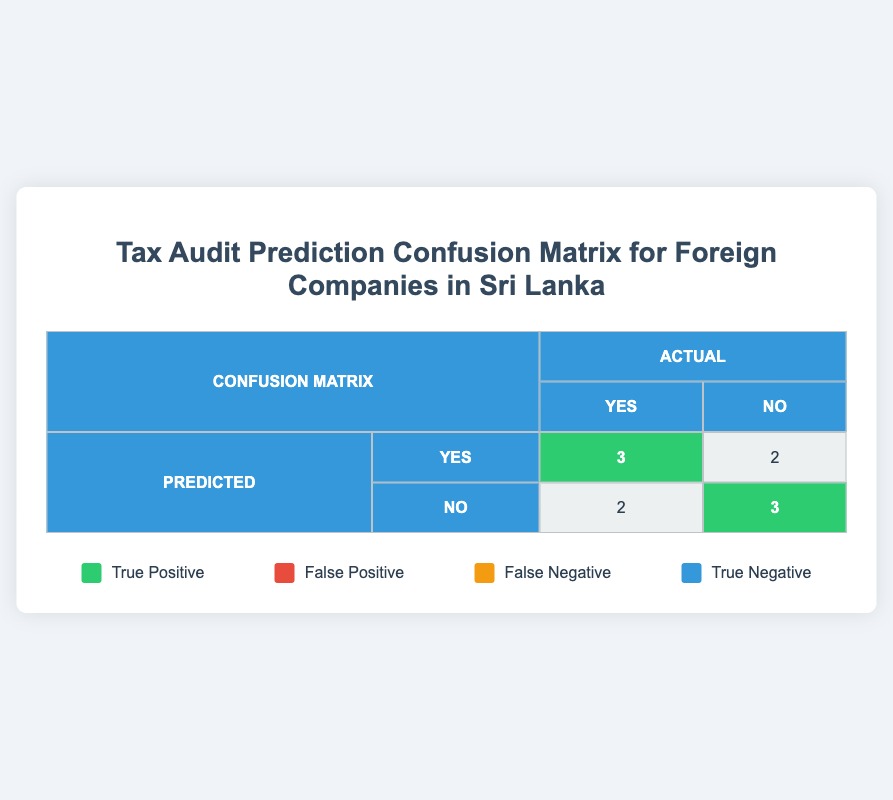What is the number of true positives? The number of true positives is represented by the cell in the first row and first column, which shows 3 instances where the predicted audit was "Yes," and the actual audit was also "Yes."
Answer: 3 How many companies were predicted to have an audit but did not actually have one? This is the number of false positives, represented by the cell in the first row and second column. It shows 2 instances where the predicted audit was "Yes," but the actual audit was "No."
Answer: 2 What is the total number of companies that actually had an audit? To find this, we look at the second row, where "Actual" audits are "Yes." Adding the true positives (3) and false negatives (2) gives us a total of 5 companies that had actual audits.
Answer: 5 What percentage of companies that were predicted to have an audit were correct in their predictions? The percentage is calculated as follows: (true positives / total predicted positives) * 100. Here, true positives are 3 and total predicted positives (3 + 2) = 5. Therefore, (3/5) * 100 = 60%.
Answer: 60% How many companies were predicted not to have an audit but did have one? This is the number of false negatives, represented by the cell in the second row, first column, which shows 2 cases where the predicted audit was "No," but the actual audit was "Yes."
Answer: 2 Was the prediction accuracy higher for audits that were correctly identified as "Yes" or "No"? To determine this, we compare true positives (3) to true negatives (3). Since both values are equal, the prediction accuracy is the same for both audits that were "Yes" and "No."
Answer: Yes What is the overall accuracy of the model in predicting audits? Overall accuracy is calculated as (true positives + true negatives) / total predictions. Here, (3 + 3) / 10 = 0.6 or 60%.
Answer: 60% How many companies were correctly identified as not needing an audit? This value is the true negatives, found in the second row, second column, showing 3 companies where the predicted audit was "No," and the actual audit was also "No."
Answer: 3 